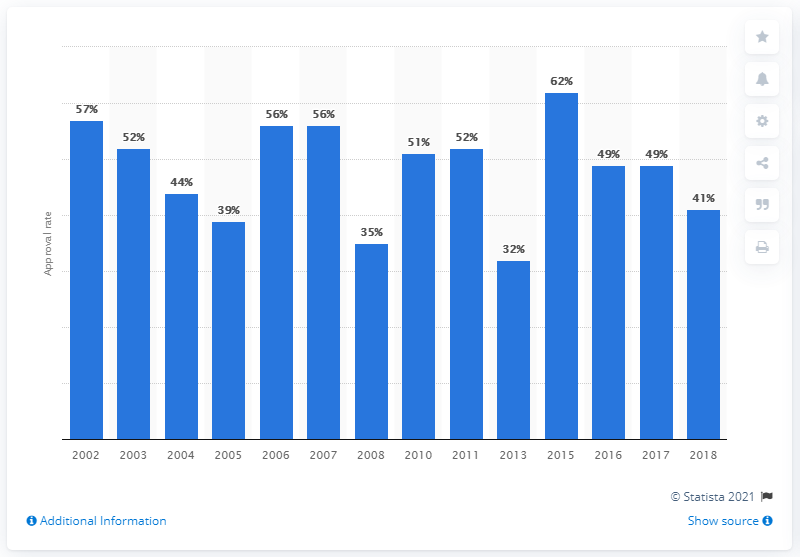Give some essential details in this illustration. The highest approval rate was registered in 2015. 